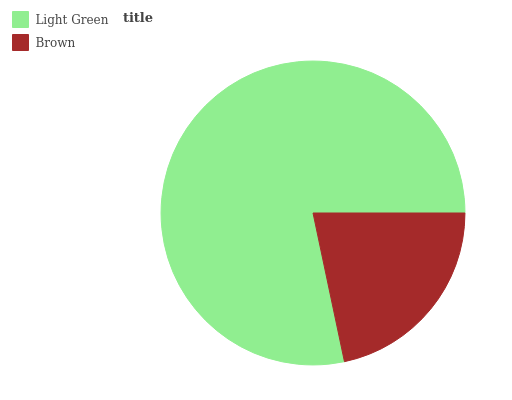Is Brown the minimum?
Answer yes or no. Yes. Is Light Green the maximum?
Answer yes or no. Yes. Is Brown the maximum?
Answer yes or no. No. Is Light Green greater than Brown?
Answer yes or no. Yes. Is Brown less than Light Green?
Answer yes or no. Yes. Is Brown greater than Light Green?
Answer yes or no. No. Is Light Green less than Brown?
Answer yes or no. No. Is Light Green the high median?
Answer yes or no. Yes. Is Brown the low median?
Answer yes or no. Yes. Is Brown the high median?
Answer yes or no. No. Is Light Green the low median?
Answer yes or no. No. 